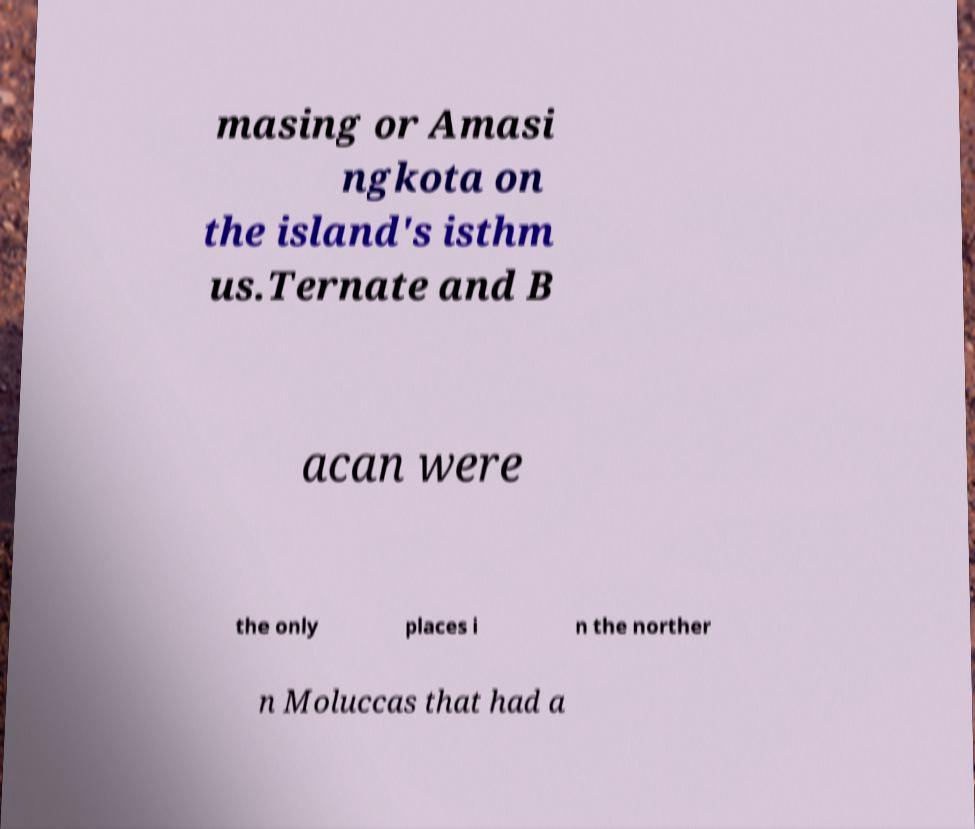For documentation purposes, I need the text within this image transcribed. Could you provide that? masing or Amasi ngkota on the island's isthm us.Ternate and B acan were the only places i n the norther n Moluccas that had a 